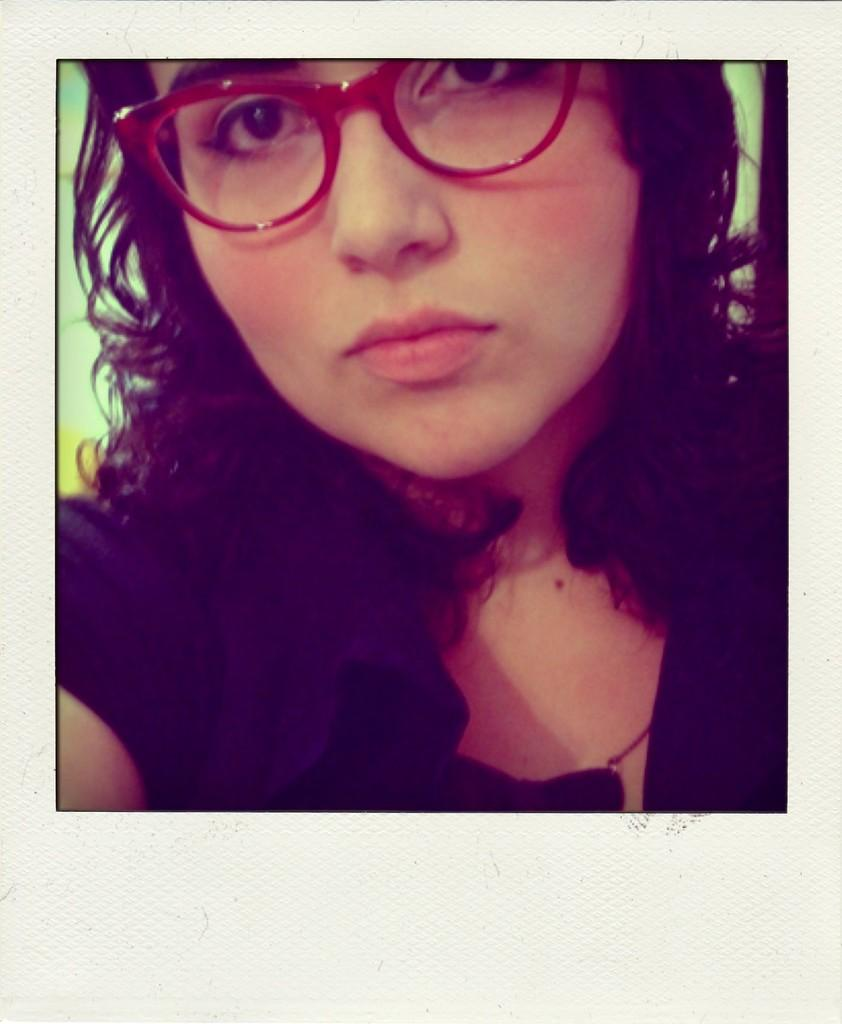Who is the main subject in the image? There is a woman in the image. What is the woman doing in the image? The woman is looking at the side. What is the woman wearing on her face? The woman is wearing red color spectacles. What is the woman wearing on her upper body? The woman is wearing a black color t-shirt. What type of pencil is the woman holding in the image? There is no pencil present in the image. What happens when the woman bursts into laughter in the image? The woman does not burst into laughter in the image; she is simply looking at the side. 